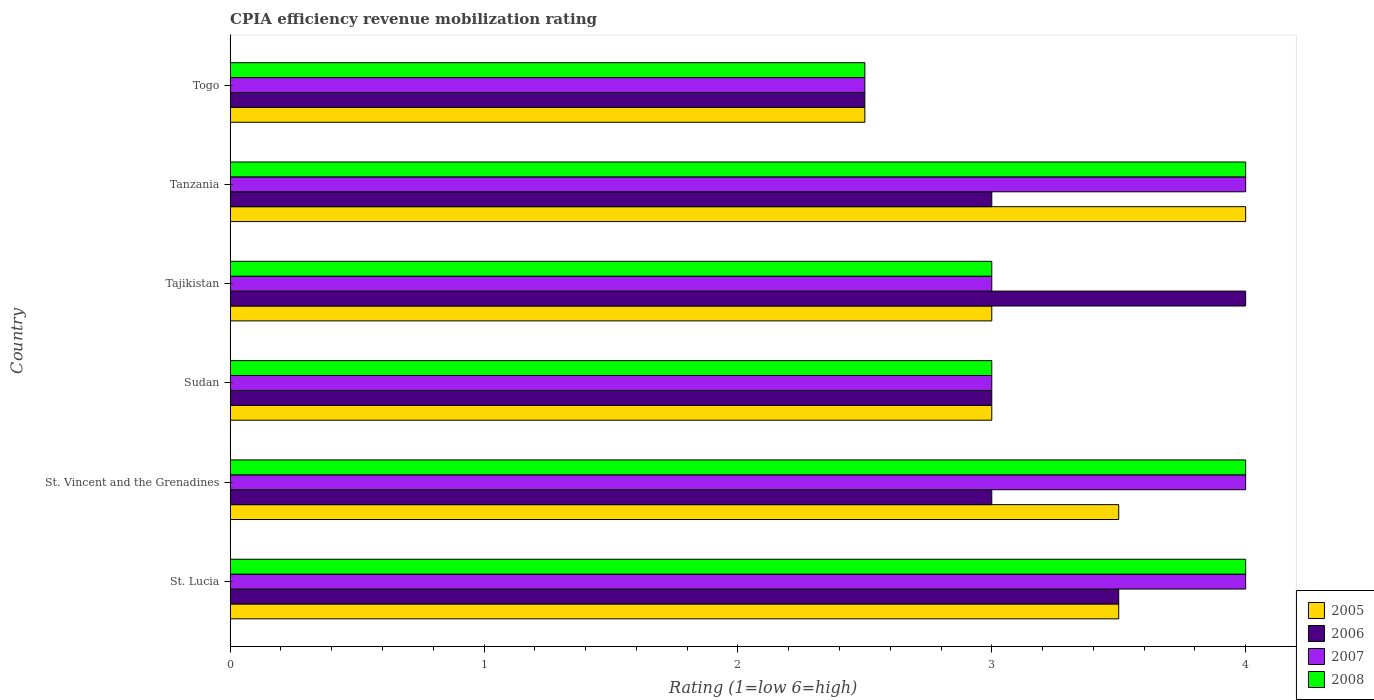How many different coloured bars are there?
Give a very brief answer. 4. Are the number of bars on each tick of the Y-axis equal?
Ensure brevity in your answer.  Yes. How many bars are there on the 6th tick from the top?
Your answer should be compact. 4. How many bars are there on the 5th tick from the bottom?
Your answer should be compact. 4. What is the label of the 2nd group of bars from the top?
Your answer should be compact. Tanzania. In how many cases, is the number of bars for a given country not equal to the number of legend labels?
Keep it short and to the point. 0. In which country was the CPIA rating in 2006 maximum?
Your answer should be very brief. Tajikistan. In which country was the CPIA rating in 2007 minimum?
Your response must be concise. Togo. What is the difference between the CPIA rating in 2007 in St. Vincent and the Grenadines and that in Tanzania?
Your answer should be compact. 0. What is the average CPIA rating in 2006 per country?
Keep it short and to the point. 3.17. In how many countries, is the CPIA rating in 2007 greater than 2 ?
Your answer should be very brief. 6. What is the ratio of the CPIA rating in 2008 in St. Lucia to that in Tajikistan?
Your answer should be compact. 1.33. Is the CPIA rating in 2007 in Tajikistan less than that in Togo?
Ensure brevity in your answer.  No. What is the difference between the highest and the second highest CPIA rating in 2007?
Give a very brief answer. 0. Is it the case that in every country, the sum of the CPIA rating in 2007 and CPIA rating in 2008 is greater than the CPIA rating in 2006?
Your response must be concise. Yes. How many bars are there?
Offer a very short reply. 24. How many countries are there in the graph?
Offer a terse response. 6. What is the difference between two consecutive major ticks on the X-axis?
Offer a terse response. 1. Does the graph contain grids?
Provide a succinct answer. No. What is the title of the graph?
Offer a very short reply. CPIA efficiency revenue mobilization rating. Does "1968" appear as one of the legend labels in the graph?
Offer a very short reply. No. What is the label or title of the Y-axis?
Make the answer very short. Country. What is the Rating (1=low 6=high) in 2005 in St. Lucia?
Keep it short and to the point. 3.5. What is the Rating (1=low 6=high) in 2006 in St. Lucia?
Ensure brevity in your answer.  3.5. What is the Rating (1=low 6=high) of 2007 in St. Lucia?
Offer a very short reply. 4. What is the Rating (1=low 6=high) in 2007 in St. Vincent and the Grenadines?
Offer a very short reply. 4. What is the Rating (1=low 6=high) of 2006 in Togo?
Offer a very short reply. 2.5. What is the Rating (1=low 6=high) of 2008 in Togo?
Give a very brief answer. 2.5. Across all countries, what is the maximum Rating (1=low 6=high) in 2006?
Offer a terse response. 4. Across all countries, what is the minimum Rating (1=low 6=high) of 2007?
Your answer should be compact. 2.5. What is the total Rating (1=low 6=high) in 2006 in the graph?
Make the answer very short. 19. What is the total Rating (1=low 6=high) of 2007 in the graph?
Provide a succinct answer. 20.5. What is the difference between the Rating (1=low 6=high) of 2006 in St. Lucia and that in St. Vincent and the Grenadines?
Provide a short and direct response. 0.5. What is the difference between the Rating (1=low 6=high) in 2007 in St. Lucia and that in St. Vincent and the Grenadines?
Provide a short and direct response. 0. What is the difference between the Rating (1=low 6=high) in 2008 in St. Lucia and that in St. Vincent and the Grenadines?
Ensure brevity in your answer.  0. What is the difference between the Rating (1=low 6=high) of 2006 in St. Lucia and that in Sudan?
Offer a very short reply. 0.5. What is the difference between the Rating (1=low 6=high) in 2006 in St. Lucia and that in Tajikistan?
Make the answer very short. -0.5. What is the difference between the Rating (1=low 6=high) of 2007 in St. Lucia and that in Tajikistan?
Provide a short and direct response. 1. What is the difference between the Rating (1=low 6=high) in 2006 in St. Lucia and that in Togo?
Your answer should be very brief. 1. What is the difference between the Rating (1=low 6=high) in 2008 in St. Lucia and that in Togo?
Your answer should be very brief. 1.5. What is the difference between the Rating (1=low 6=high) in 2005 in St. Vincent and the Grenadines and that in Sudan?
Offer a very short reply. 0.5. What is the difference between the Rating (1=low 6=high) in 2006 in St. Vincent and the Grenadines and that in Sudan?
Ensure brevity in your answer.  0. What is the difference between the Rating (1=low 6=high) of 2007 in St. Vincent and the Grenadines and that in Sudan?
Offer a terse response. 1. What is the difference between the Rating (1=low 6=high) in 2008 in St. Vincent and the Grenadines and that in Sudan?
Ensure brevity in your answer.  1. What is the difference between the Rating (1=low 6=high) in 2005 in St. Vincent and the Grenadines and that in Tajikistan?
Offer a terse response. 0.5. What is the difference between the Rating (1=low 6=high) of 2007 in St. Vincent and the Grenadines and that in Tajikistan?
Your response must be concise. 1. What is the difference between the Rating (1=low 6=high) of 2005 in St. Vincent and the Grenadines and that in Tanzania?
Your answer should be very brief. -0.5. What is the difference between the Rating (1=low 6=high) in 2005 in St. Vincent and the Grenadines and that in Togo?
Keep it short and to the point. 1. What is the difference between the Rating (1=low 6=high) in 2008 in St. Vincent and the Grenadines and that in Togo?
Your answer should be compact. 1.5. What is the difference between the Rating (1=low 6=high) in 2005 in Sudan and that in Tajikistan?
Your answer should be compact. 0. What is the difference between the Rating (1=low 6=high) of 2007 in Sudan and that in Tajikistan?
Make the answer very short. 0. What is the difference between the Rating (1=low 6=high) of 2008 in Sudan and that in Tajikistan?
Ensure brevity in your answer.  0. What is the difference between the Rating (1=low 6=high) of 2006 in Sudan and that in Tanzania?
Provide a short and direct response. 0. What is the difference between the Rating (1=low 6=high) in 2007 in Sudan and that in Tanzania?
Your response must be concise. -1. What is the difference between the Rating (1=low 6=high) of 2008 in Sudan and that in Tanzania?
Provide a short and direct response. -1. What is the difference between the Rating (1=low 6=high) in 2005 in Sudan and that in Togo?
Your answer should be very brief. 0.5. What is the difference between the Rating (1=low 6=high) in 2006 in Sudan and that in Togo?
Keep it short and to the point. 0.5. What is the difference between the Rating (1=low 6=high) in 2007 in Sudan and that in Togo?
Offer a terse response. 0.5. What is the difference between the Rating (1=low 6=high) of 2007 in Tajikistan and that in Togo?
Your answer should be very brief. 0.5. What is the difference between the Rating (1=low 6=high) in 2005 in Tanzania and that in Togo?
Provide a short and direct response. 1.5. What is the difference between the Rating (1=low 6=high) of 2007 in Tanzania and that in Togo?
Your answer should be very brief. 1.5. What is the difference between the Rating (1=low 6=high) of 2008 in Tanzania and that in Togo?
Your response must be concise. 1.5. What is the difference between the Rating (1=low 6=high) of 2005 in St. Lucia and the Rating (1=low 6=high) of 2006 in St. Vincent and the Grenadines?
Ensure brevity in your answer.  0.5. What is the difference between the Rating (1=low 6=high) of 2005 in St. Lucia and the Rating (1=low 6=high) of 2008 in St. Vincent and the Grenadines?
Ensure brevity in your answer.  -0.5. What is the difference between the Rating (1=low 6=high) in 2007 in St. Lucia and the Rating (1=low 6=high) in 2008 in St. Vincent and the Grenadines?
Your answer should be very brief. 0. What is the difference between the Rating (1=low 6=high) of 2005 in St. Lucia and the Rating (1=low 6=high) of 2007 in Sudan?
Your answer should be compact. 0.5. What is the difference between the Rating (1=low 6=high) of 2005 in St. Lucia and the Rating (1=low 6=high) of 2008 in Sudan?
Give a very brief answer. 0.5. What is the difference between the Rating (1=low 6=high) in 2005 in St. Lucia and the Rating (1=low 6=high) in 2007 in Tajikistan?
Ensure brevity in your answer.  0.5. What is the difference between the Rating (1=low 6=high) in 2005 in St. Lucia and the Rating (1=low 6=high) in 2008 in Tajikistan?
Provide a succinct answer. 0.5. What is the difference between the Rating (1=low 6=high) in 2006 in St. Lucia and the Rating (1=low 6=high) in 2007 in Tajikistan?
Give a very brief answer. 0.5. What is the difference between the Rating (1=low 6=high) in 2007 in St. Lucia and the Rating (1=low 6=high) in 2008 in Tajikistan?
Your answer should be compact. 1. What is the difference between the Rating (1=low 6=high) in 2005 in St. Lucia and the Rating (1=low 6=high) in 2007 in Tanzania?
Make the answer very short. -0.5. What is the difference between the Rating (1=low 6=high) of 2006 in St. Lucia and the Rating (1=low 6=high) of 2008 in Tanzania?
Make the answer very short. -0.5. What is the difference between the Rating (1=low 6=high) in 2007 in St. Lucia and the Rating (1=low 6=high) in 2008 in Tanzania?
Offer a terse response. 0. What is the difference between the Rating (1=low 6=high) in 2005 in St. Lucia and the Rating (1=low 6=high) in 2006 in Togo?
Keep it short and to the point. 1. What is the difference between the Rating (1=low 6=high) of 2005 in St. Lucia and the Rating (1=low 6=high) of 2008 in Togo?
Give a very brief answer. 1. What is the difference between the Rating (1=low 6=high) of 2005 in St. Vincent and the Grenadines and the Rating (1=low 6=high) of 2007 in Sudan?
Your response must be concise. 0.5. What is the difference between the Rating (1=low 6=high) of 2005 in St. Vincent and the Grenadines and the Rating (1=low 6=high) of 2008 in Sudan?
Provide a short and direct response. 0.5. What is the difference between the Rating (1=low 6=high) in 2006 in St. Vincent and the Grenadines and the Rating (1=low 6=high) in 2007 in Sudan?
Ensure brevity in your answer.  0. What is the difference between the Rating (1=low 6=high) in 2007 in St. Vincent and the Grenadines and the Rating (1=low 6=high) in 2008 in Sudan?
Your response must be concise. 1. What is the difference between the Rating (1=low 6=high) in 2005 in St. Vincent and the Grenadines and the Rating (1=low 6=high) in 2008 in Tajikistan?
Provide a short and direct response. 0.5. What is the difference between the Rating (1=low 6=high) in 2006 in St. Vincent and the Grenadines and the Rating (1=low 6=high) in 2007 in Tajikistan?
Provide a short and direct response. 0. What is the difference between the Rating (1=low 6=high) in 2006 in St. Vincent and the Grenadines and the Rating (1=low 6=high) in 2007 in Tanzania?
Provide a succinct answer. -1. What is the difference between the Rating (1=low 6=high) in 2005 in St. Vincent and the Grenadines and the Rating (1=low 6=high) in 2007 in Togo?
Provide a succinct answer. 1. What is the difference between the Rating (1=low 6=high) of 2007 in St. Vincent and the Grenadines and the Rating (1=low 6=high) of 2008 in Togo?
Offer a very short reply. 1.5. What is the difference between the Rating (1=low 6=high) of 2005 in Sudan and the Rating (1=low 6=high) of 2007 in Tajikistan?
Offer a terse response. 0. What is the difference between the Rating (1=low 6=high) of 2006 in Sudan and the Rating (1=low 6=high) of 2008 in Tajikistan?
Provide a short and direct response. 0. What is the difference between the Rating (1=low 6=high) of 2007 in Sudan and the Rating (1=low 6=high) of 2008 in Tajikistan?
Offer a very short reply. 0. What is the difference between the Rating (1=low 6=high) of 2005 in Sudan and the Rating (1=low 6=high) of 2006 in Tanzania?
Provide a succinct answer. 0. What is the difference between the Rating (1=low 6=high) of 2005 in Sudan and the Rating (1=low 6=high) of 2007 in Tanzania?
Make the answer very short. -1. What is the difference between the Rating (1=low 6=high) in 2005 in Sudan and the Rating (1=low 6=high) in 2008 in Tanzania?
Offer a terse response. -1. What is the difference between the Rating (1=low 6=high) in 2006 in Sudan and the Rating (1=low 6=high) in 2008 in Tanzania?
Give a very brief answer. -1. What is the difference between the Rating (1=low 6=high) in 2005 in Sudan and the Rating (1=low 6=high) in 2006 in Togo?
Provide a succinct answer. 0.5. What is the difference between the Rating (1=low 6=high) of 2005 in Sudan and the Rating (1=low 6=high) of 2007 in Togo?
Provide a succinct answer. 0.5. What is the difference between the Rating (1=low 6=high) in 2005 in Sudan and the Rating (1=low 6=high) in 2008 in Togo?
Ensure brevity in your answer.  0.5. What is the difference between the Rating (1=low 6=high) of 2006 in Sudan and the Rating (1=low 6=high) of 2008 in Togo?
Offer a terse response. 0.5. What is the difference between the Rating (1=low 6=high) in 2005 in Tajikistan and the Rating (1=low 6=high) in 2006 in Tanzania?
Offer a very short reply. 0. What is the difference between the Rating (1=low 6=high) of 2005 in Tajikistan and the Rating (1=low 6=high) of 2007 in Tanzania?
Give a very brief answer. -1. What is the difference between the Rating (1=low 6=high) of 2005 in Tajikistan and the Rating (1=low 6=high) of 2008 in Tanzania?
Offer a terse response. -1. What is the difference between the Rating (1=low 6=high) in 2006 in Tajikistan and the Rating (1=low 6=high) in 2007 in Tanzania?
Your response must be concise. 0. What is the difference between the Rating (1=low 6=high) in 2006 in Tajikistan and the Rating (1=low 6=high) in 2008 in Tanzania?
Your answer should be very brief. 0. What is the difference between the Rating (1=low 6=high) in 2007 in Tajikistan and the Rating (1=low 6=high) in 2008 in Tanzania?
Your answer should be very brief. -1. What is the difference between the Rating (1=low 6=high) in 2005 in Tajikistan and the Rating (1=low 6=high) in 2006 in Togo?
Give a very brief answer. 0.5. What is the difference between the Rating (1=low 6=high) of 2005 in Tajikistan and the Rating (1=low 6=high) of 2007 in Togo?
Offer a very short reply. 0.5. What is the difference between the Rating (1=low 6=high) in 2005 in Tajikistan and the Rating (1=low 6=high) in 2008 in Togo?
Make the answer very short. 0.5. What is the difference between the Rating (1=low 6=high) of 2006 in Tajikistan and the Rating (1=low 6=high) of 2007 in Togo?
Your answer should be compact. 1.5. What is the difference between the Rating (1=low 6=high) in 2005 in Tanzania and the Rating (1=low 6=high) in 2006 in Togo?
Offer a terse response. 1.5. What is the difference between the Rating (1=low 6=high) of 2005 in Tanzania and the Rating (1=low 6=high) of 2008 in Togo?
Provide a short and direct response. 1.5. What is the average Rating (1=low 6=high) of 2006 per country?
Offer a very short reply. 3.17. What is the average Rating (1=low 6=high) in 2007 per country?
Your answer should be very brief. 3.42. What is the average Rating (1=low 6=high) of 2008 per country?
Give a very brief answer. 3.42. What is the difference between the Rating (1=low 6=high) of 2005 and Rating (1=low 6=high) of 2006 in St. Lucia?
Offer a terse response. 0. What is the difference between the Rating (1=low 6=high) of 2006 and Rating (1=low 6=high) of 2008 in St. Lucia?
Your response must be concise. -0.5. What is the difference between the Rating (1=low 6=high) in 2005 and Rating (1=low 6=high) in 2008 in St. Vincent and the Grenadines?
Offer a very short reply. -0.5. What is the difference between the Rating (1=low 6=high) in 2006 and Rating (1=low 6=high) in 2008 in St. Vincent and the Grenadines?
Your answer should be compact. -1. What is the difference between the Rating (1=low 6=high) of 2007 and Rating (1=low 6=high) of 2008 in St. Vincent and the Grenadines?
Provide a succinct answer. 0. What is the difference between the Rating (1=low 6=high) of 2005 and Rating (1=low 6=high) of 2008 in Sudan?
Provide a succinct answer. 0. What is the difference between the Rating (1=low 6=high) of 2006 and Rating (1=low 6=high) of 2007 in Sudan?
Your answer should be compact. 0. What is the difference between the Rating (1=low 6=high) of 2005 and Rating (1=low 6=high) of 2006 in Tajikistan?
Ensure brevity in your answer.  -1. What is the difference between the Rating (1=low 6=high) in 2005 and Rating (1=low 6=high) in 2007 in Tajikistan?
Your response must be concise. 0. What is the difference between the Rating (1=low 6=high) of 2005 and Rating (1=low 6=high) of 2008 in Tajikistan?
Offer a very short reply. 0. What is the difference between the Rating (1=low 6=high) in 2006 and Rating (1=low 6=high) in 2008 in Tajikistan?
Give a very brief answer. 1. What is the difference between the Rating (1=low 6=high) of 2007 and Rating (1=low 6=high) of 2008 in Tajikistan?
Ensure brevity in your answer.  0. What is the difference between the Rating (1=low 6=high) in 2005 and Rating (1=low 6=high) in 2006 in Tanzania?
Offer a terse response. 1. What is the difference between the Rating (1=low 6=high) of 2005 and Rating (1=low 6=high) of 2007 in Tanzania?
Provide a short and direct response. 0. What is the difference between the Rating (1=low 6=high) in 2005 and Rating (1=low 6=high) in 2008 in Tanzania?
Provide a short and direct response. 0. What is the difference between the Rating (1=low 6=high) in 2006 and Rating (1=low 6=high) in 2007 in Tanzania?
Provide a short and direct response. -1. What is the difference between the Rating (1=low 6=high) of 2006 and Rating (1=low 6=high) of 2008 in Tanzania?
Your answer should be very brief. -1. What is the difference between the Rating (1=low 6=high) in 2005 and Rating (1=low 6=high) in 2006 in Togo?
Ensure brevity in your answer.  0. What is the difference between the Rating (1=low 6=high) in 2005 and Rating (1=low 6=high) in 2007 in Togo?
Keep it short and to the point. 0. What is the difference between the Rating (1=low 6=high) of 2005 and Rating (1=low 6=high) of 2008 in Togo?
Provide a succinct answer. 0. What is the difference between the Rating (1=low 6=high) in 2006 and Rating (1=low 6=high) in 2008 in Togo?
Give a very brief answer. 0. What is the ratio of the Rating (1=low 6=high) of 2006 in St. Lucia to that in St. Vincent and the Grenadines?
Your response must be concise. 1.17. What is the ratio of the Rating (1=low 6=high) in 2008 in St. Lucia to that in St. Vincent and the Grenadines?
Your response must be concise. 1. What is the ratio of the Rating (1=low 6=high) in 2006 in St. Lucia to that in Sudan?
Your answer should be very brief. 1.17. What is the ratio of the Rating (1=low 6=high) in 2007 in St. Lucia to that in Sudan?
Provide a succinct answer. 1.33. What is the ratio of the Rating (1=low 6=high) in 2006 in St. Lucia to that in Tajikistan?
Ensure brevity in your answer.  0.88. What is the ratio of the Rating (1=low 6=high) of 2005 in St. Lucia to that in Tanzania?
Provide a short and direct response. 0.88. What is the ratio of the Rating (1=low 6=high) in 2007 in St. Lucia to that in Tanzania?
Your answer should be compact. 1. What is the ratio of the Rating (1=low 6=high) in 2008 in St. Lucia to that in Tanzania?
Ensure brevity in your answer.  1. What is the ratio of the Rating (1=low 6=high) of 2008 in St. Lucia to that in Togo?
Make the answer very short. 1.6. What is the ratio of the Rating (1=low 6=high) of 2005 in St. Vincent and the Grenadines to that in Sudan?
Give a very brief answer. 1.17. What is the ratio of the Rating (1=low 6=high) in 2008 in St. Vincent and the Grenadines to that in Sudan?
Ensure brevity in your answer.  1.33. What is the ratio of the Rating (1=low 6=high) in 2008 in St. Vincent and the Grenadines to that in Tajikistan?
Give a very brief answer. 1.33. What is the ratio of the Rating (1=low 6=high) of 2008 in St. Vincent and the Grenadines to that in Tanzania?
Give a very brief answer. 1. What is the ratio of the Rating (1=low 6=high) in 2008 in St. Vincent and the Grenadines to that in Togo?
Make the answer very short. 1.6. What is the ratio of the Rating (1=low 6=high) of 2006 in Sudan to that in Tajikistan?
Keep it short and to the point. 0.75. What is the ratio of the Rating (1=low 6=high) of 2007 in Sudan to that in Tajikistan?
Provide a short and direct response. 1. What is the ratio of the Rating (1=low 6=high) of 2005 in Sudan to that in Tanzania?
Your answer should be compact. 0.75. What is the ratio of the Rating (1=low 6=high) of 2006 in Sudan to that in Tanzania?
Provide a short and direct response. 1. What is the ratio of the Rating (1=low 6=high) in 2007 in Sudan to that in Tanzania?
Offer a very short reply. 0.75. What is the ratio of the Rating (1=low 6=high) in 2008 in Sudan to that in Tanzania?
Provide a short and direct response. 0.75. What is the ratio of the Rating (1=low 6=high) of 2005 in Tajikistan to that in Tanzania?
Your response must be concise. 0.75. What is the ratio of the Rating (1=low 6=high) in 2007 in Tajikistan to that in Tanzania?
Provide a short and direct response. 0.75. What is the ratio of the Rating (1=low 6=high) in 2006 in Tajikistan to that in Togo?
Ensure brevity in your answer.  1.6. What is the ratio of the Rating (1=low 6=high) of 2006 in Tanzania to that in Togo?
Keep it short and to the point. 1.2. What is the ratio of the Rating (1=low 6=high) in 2008 in Tanzania to that in Togo?
Your answer should be compact. 1.6. What is the difference between the highest and the second highest Rating (1=low 6=high) of 2006?
Offer a very short reply. 0.5. What is the difference between the highest and the second highest Rating (1=low 6=high) of 2008?
Your response must be concise. 0. What is the difference between the highest and the lowest Rating (1=low 6=high) in 2007?
Your response must be concise. 1.5. 